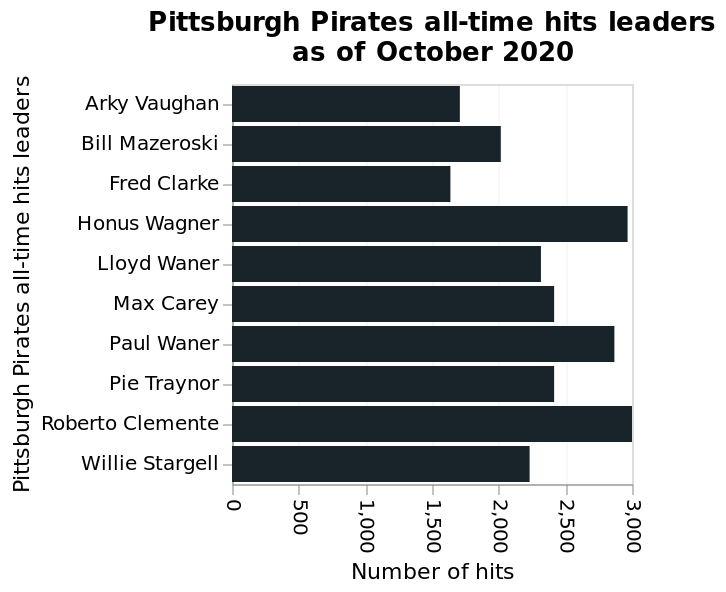<image>
What time frame does the bar graph represent? The bar graph represents the all-time hits leaders for the Pittsburgh Pirates as of October 2020. 